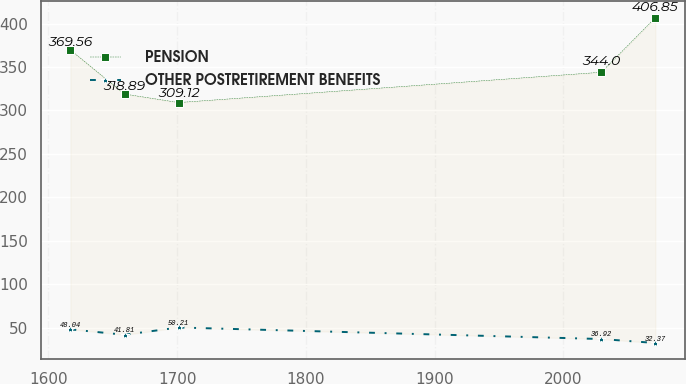Convert chart. <chart><loc_0><loc_0><loc_500><loc_500><line_chart><ecel><fcel>PENSION<fcel>OTHER POSTRETIREMENT BENEFITS<nl><fcel>1617.06<fcel>369.56<fcel>48.04<nl><fcel>1659.1<fcel>318.89<fcel>41.81<nl><fcel>1701.14<fcel>309.12<fcel>50.21<nl><fcel>2029.6<fcel>344<fcel>36.92<nl><fcel>2071.64<fcel>406.85<fcel>32.37<nl></chart> 